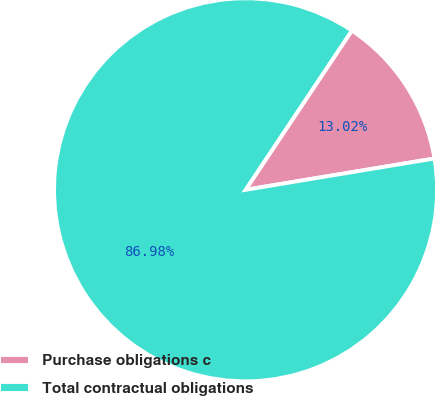<chart> <loc_0><loc_0><loc_500><loc_500><pie_chart><fcel>Purchase obligations c<fcel>Total contractual obligations<nl><fcel>13.02%<fcel>86.98%<nl></chart> 